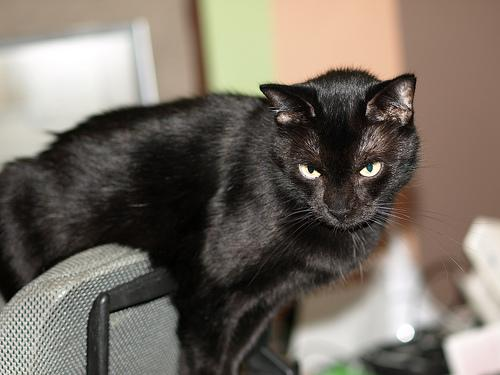Question: what color is the cat?
Choices:
A. White.
B. Brown.
C. Yellow.
D. Black.
Answer with the letter. Answer: D Question: how many cats are there?
Choices:
A. Two.
B. Three.
C. Four.
D. One.
Answer with the letter. Answer: D Question: what color is the chair?
Choices:
A. White.
B. Black.
C. Brown.
D. Gray.
Answer with the letter. Answer: D Question: what color are the inside of the cats ears?
Choices:
A. White.
B. Grey.
C. Orange.
D. Pink.
Answer with the letter. Answer: D Question: how many of the cats legs do you see?
Choices:
A. Two.
B. Three.
C. Four.
D. One.
Answer with the letter. Answer: A 